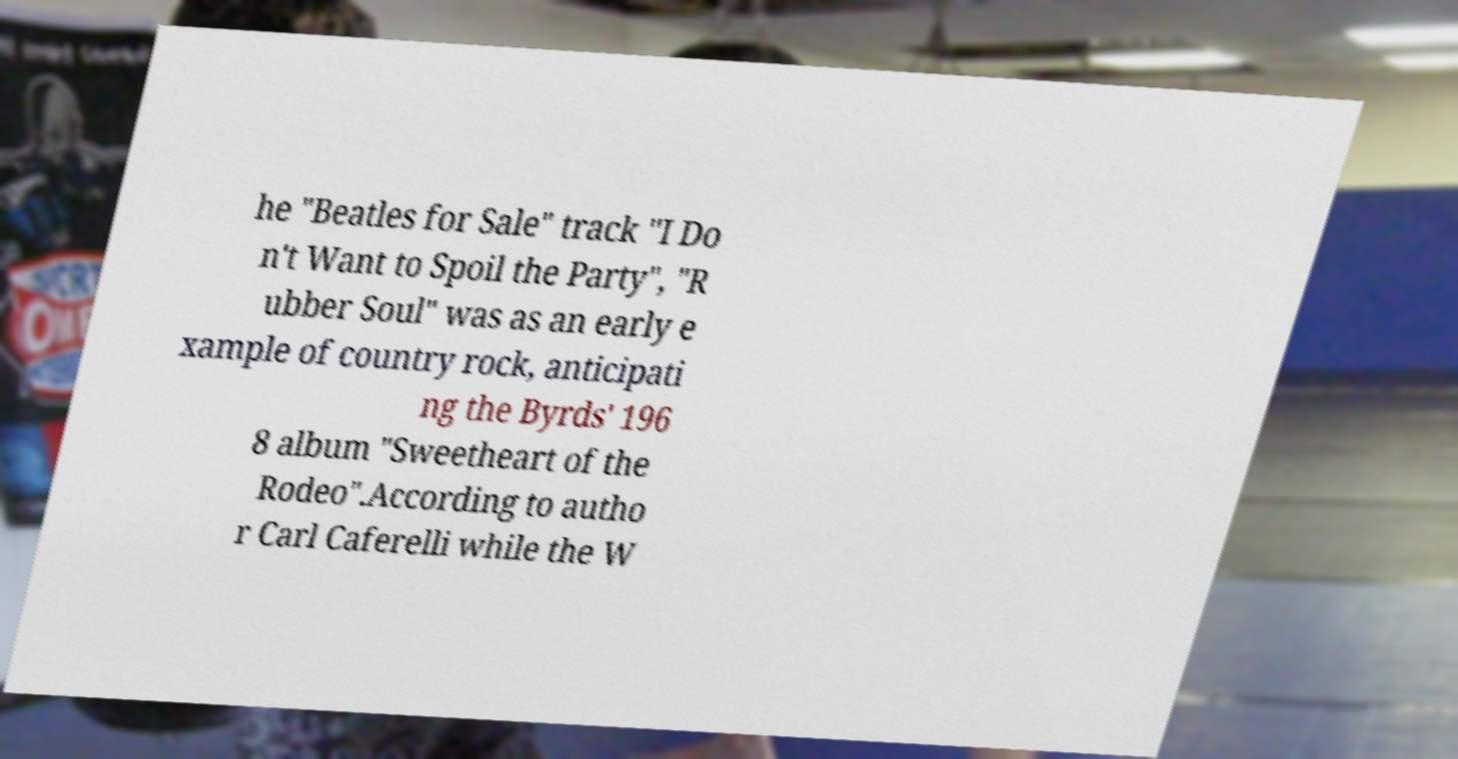For documentation purposes, I need the text within this image transcribed. Could you provide that? he "Beatles for Sale" track "I Do n't Want to Spoil the Party", "R ubber Soul" was as an early e xample of country rock, anticipati ng the Byrds' 196 8 album "Sweetheart of the Rodeo".According to autho r Carl Caferelli while the W 